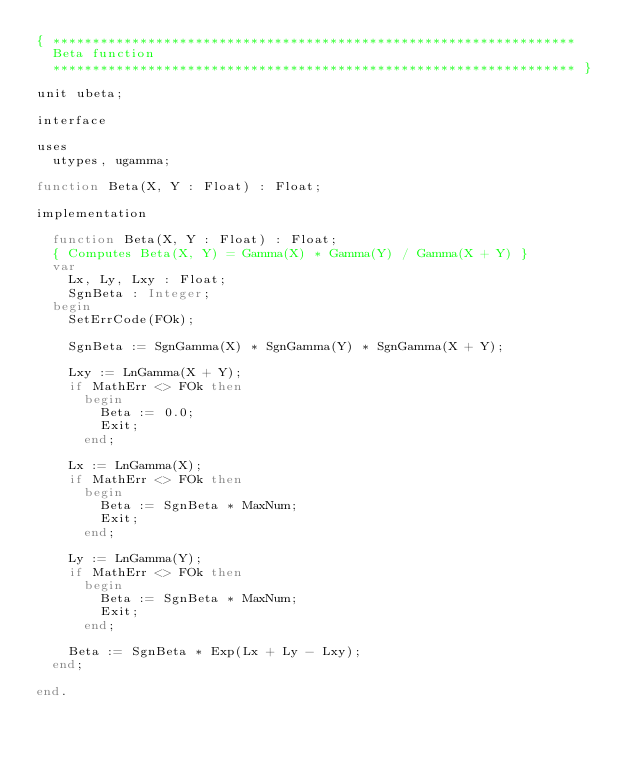Convert code to text. <code><loc_0><loc_0><loc_500><loc_500><_Pascal_>{ ******************************************************************
  Beta function
  ****************************************************************** }

unit ubeta;

interface

uses
  utypes, ugamma;

function Beta(X, Y : Float) : Float;

implementation

  function Beta(X, Y : Float) : Float;
  { Computes Beta(X, Y) = Gamma(X) * Gamma(Y) / Gamma(X + Y) }
  var
    Lx, Ly, Lxy : Float;
    SgnBeta : Integer;
  begin
    SetErrCode(FOk);

    SgnBeta := SgnGamma(X) * SgnGamma(Y) * SgnGamma(X + Y);

    Lxy := LnGamma(X + Y);
    if MathErr <> FOk then
      begin
        Beta := 0.0;
        Exit;
      end;

    Lx := LnGamma(X);
    if MathErr <> FOk then
      begin
        Beta := SgnBeta * MaxNum;
        Exit;
      end;

    Ly := LnGamma(Y);
    if MathErr <> FOk then
      begin
        Beta := SgnBeta * MaxNum;
        Exit;
      end;

    Beta := SgnBeta * Exp(Lx + Ly - Lxy);
  end;

end.</code> 